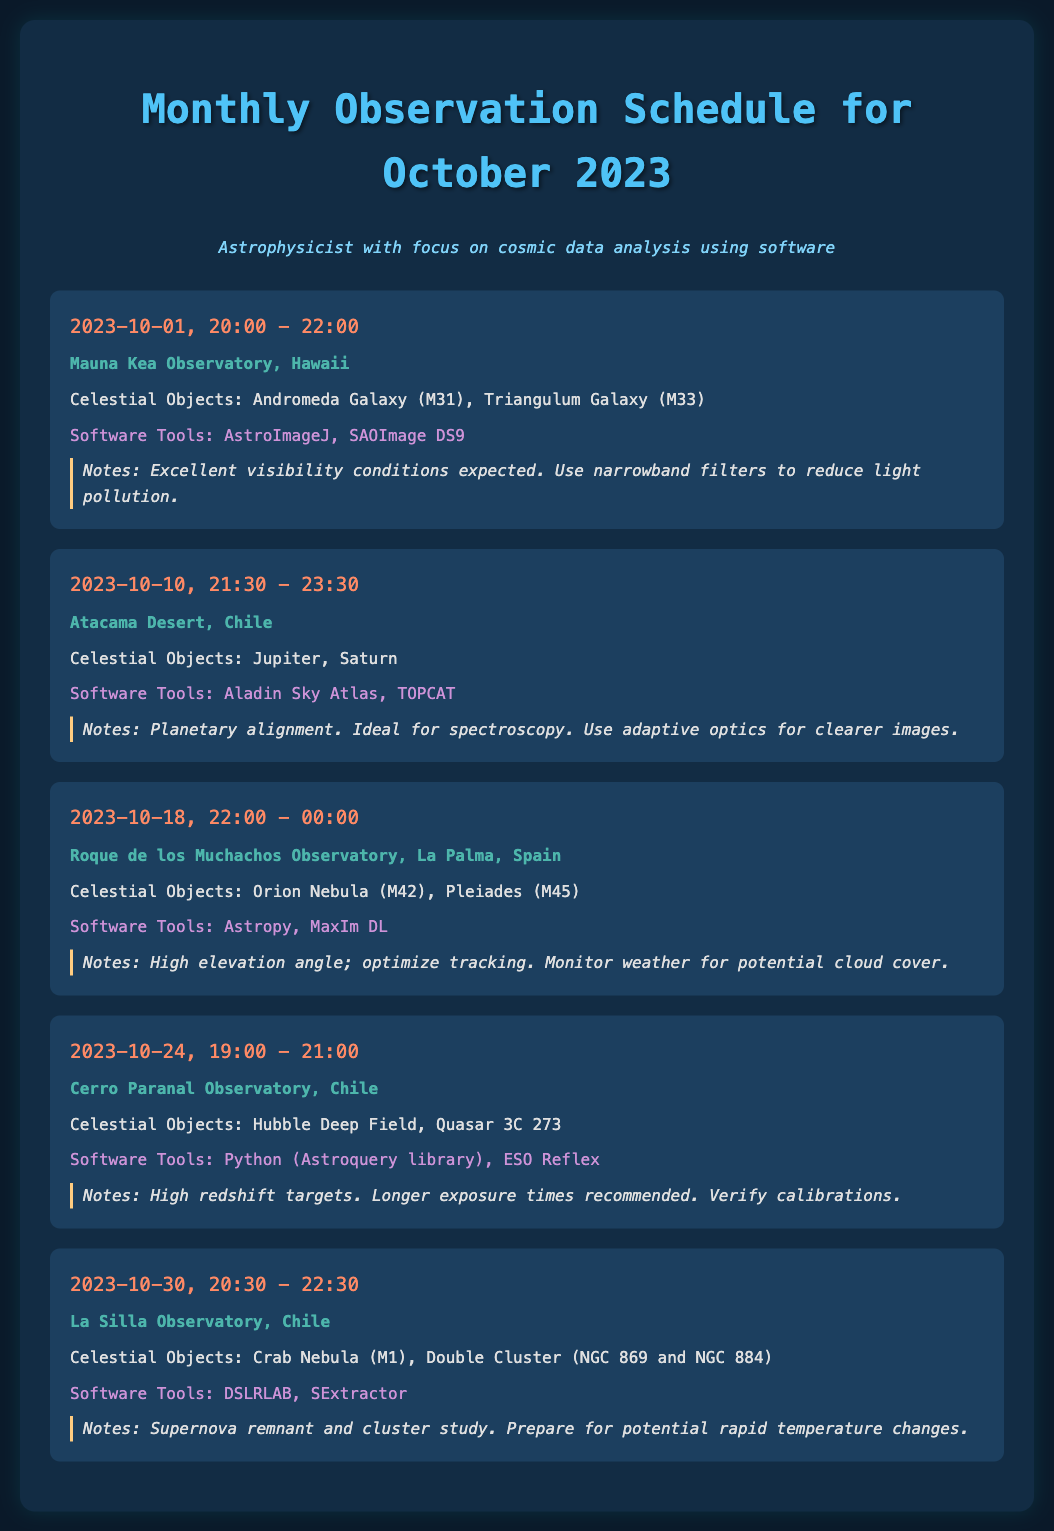What is the date of the first observation session? The first observation session is scheduled for October 1, 2023.
Answer: October 1, 2023 What celestial objects will be observed on October 10? The celestial objects on October 10 are Jupiter and Saturn.
Answer: Jupiter, Saturn What software tools are recommended for analyzing data from the Orion Nebula observation? For the Orion Nebula observation, Astropy and MaxIm DL are recommended software tools.
Answer: Astropy, MaxIm DL How many total observation sessions are scheduled in October 2023? There are five observation sessions scheduled in October 2023.
Answer: Five What is the location for the observation on October 30? The observation on October 30 will take place at La Silla Observatory, Chile.
Answer: La Silla Observatory, Chile What notes are provided for the observation of Hubble Deep Field? The notes indicate high redshift targets and recommend longer exposure times and verifying calibrations.
Answer: High redshift targets. Longer exposure times recommended. Verify calibrations Which observation session has the earliest starting time? The observation session with the earliest starting time is on October 1st at 20:00.
Answer: October 1, 20:00 What is the time duration for the observation on October 24? The observation on October 24 is scheduled for a duration of two hours, from 19:00 to 21:00.
Answer: Two hours What are the celestial objects scheduled for observation at the Atacama Desert? The celestial objects scheduled for observation at the Atacama Desert are Jupiter and Saturn.
Answer: Jupiter, Saturn 